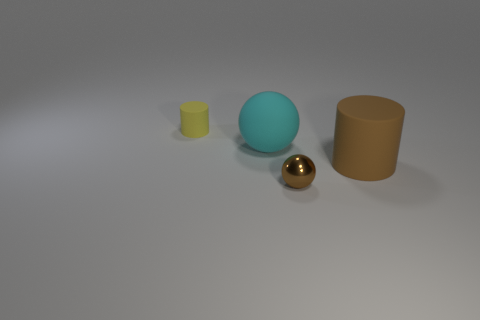Add 2 cylinders. How many objects exist? 6 Subtract all large matte spheres. Subtract all brown matte objects. How many objects are left? 2 Add 4 brown metal spheres. How many brown metal spheres are left? 5 Add 4 metallic spheres. How many metallic spheres exist? 5 Subtract 0 blue cylinders. How many objects are left? 4 